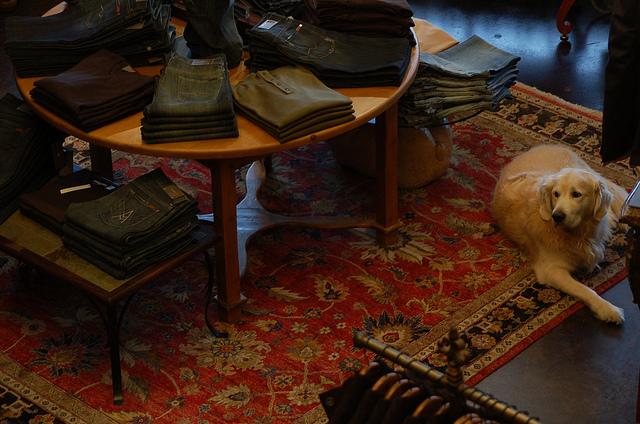What sort of furniture is behind the dog?
Concise answer only. Table. Is this a clothing store?
Be succinct. No. What color is the dog?
Short answer required. Tan. What does the dog want?
Give a very brief answer. Food. Is the dog wearing a bow on its head?
Answer briefly. No. What is the dog sitting on?
Concise answer only. Rug. What kind of dog is that?
Answer briefly. Golden retriever. What kind of animal is this?
Write a very short answer. Dog. What do the legs of the chair resemble?
Be succinct. Legs. What is the dogs comfort level?
Be succinct. Relaxed. Where is the area rug?
Keep it brief. On floor. Does the dog looked scared?
Keep it brief. No. Which color is the dog?
Answer briefly. Yellow. What animals are in the picture?
Concise answer only. Dog. Is the dog fully grown?
Give a very brief answer. Yes. What is the dog standing on?
Short answer required. Rug. What type of dog is this?
Concise answer only. Golden retriever. 